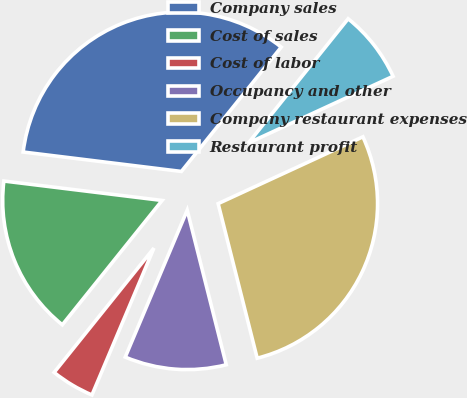Convert chart to OTSL. <chart><loc_0><loc_0><loc_500><loc_500><pie_chart><fcel>Company sales<fcel>Cost of sales<fcel>Cost of labor<fcel>Occupancy and other<fcel>Company restaurant expenses<fcel>Restaurant profit<nl><fcel>33.82%<fcel>16.18%<fcel>4.41%<fcel>10.29%<fcel>27.94%<fcel>7.35%<nl></chart> 